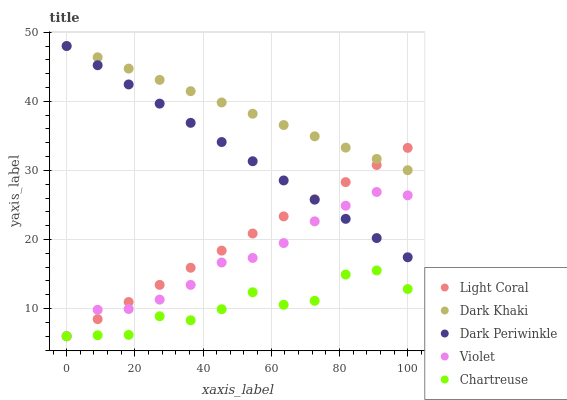Does Chartreuse have the minimum area under the curve?
Answer yes or no. Yes. Does Dark Khaki have the maximum area under the curve?
Answer yes or no. Yes. Does Dark Khaki have the minimum area under the curve?
Answer yes or no. No. Does Chartreuse have the maximum area under the curve?
Answer yes or no. No. Is Light Coral the smoothest?
Answer yes or no. Yes. Is Chartreuse the roughest?
Answer yes or no. Yes. Is Dark Khaki the smoothest?
Answer yes or no. No. Is Dark Khaki the roughest?
Answer yes or no. No. Does Light Coral have the lowest value?
Answer yes or no. Yes. Does Dark Khaki have the lowest value?
Answer yes or no. No. Does Dark Periwinkle have the highest value?
Answer yes or no. Yes. Does Chartreuse have the highest value?
Answer yes or no. No. Is Violet less than Dark Khaki?
Answer yes or no. Yes. Is Dark Periwinkle greater than Chartreuse?
Answer yes or no. Yes. Does Light Coral intersect Dark Periwinkle?
Answer yes or no. Yes. Is Light Coral less than Dark Periwinkle?
Answer yes or no. No. Is Light Coral greater than Dark Periwinkle?
Answer yes or no. No. Does Violet intersect Dark Khaki?
Answer yes or no. No. 